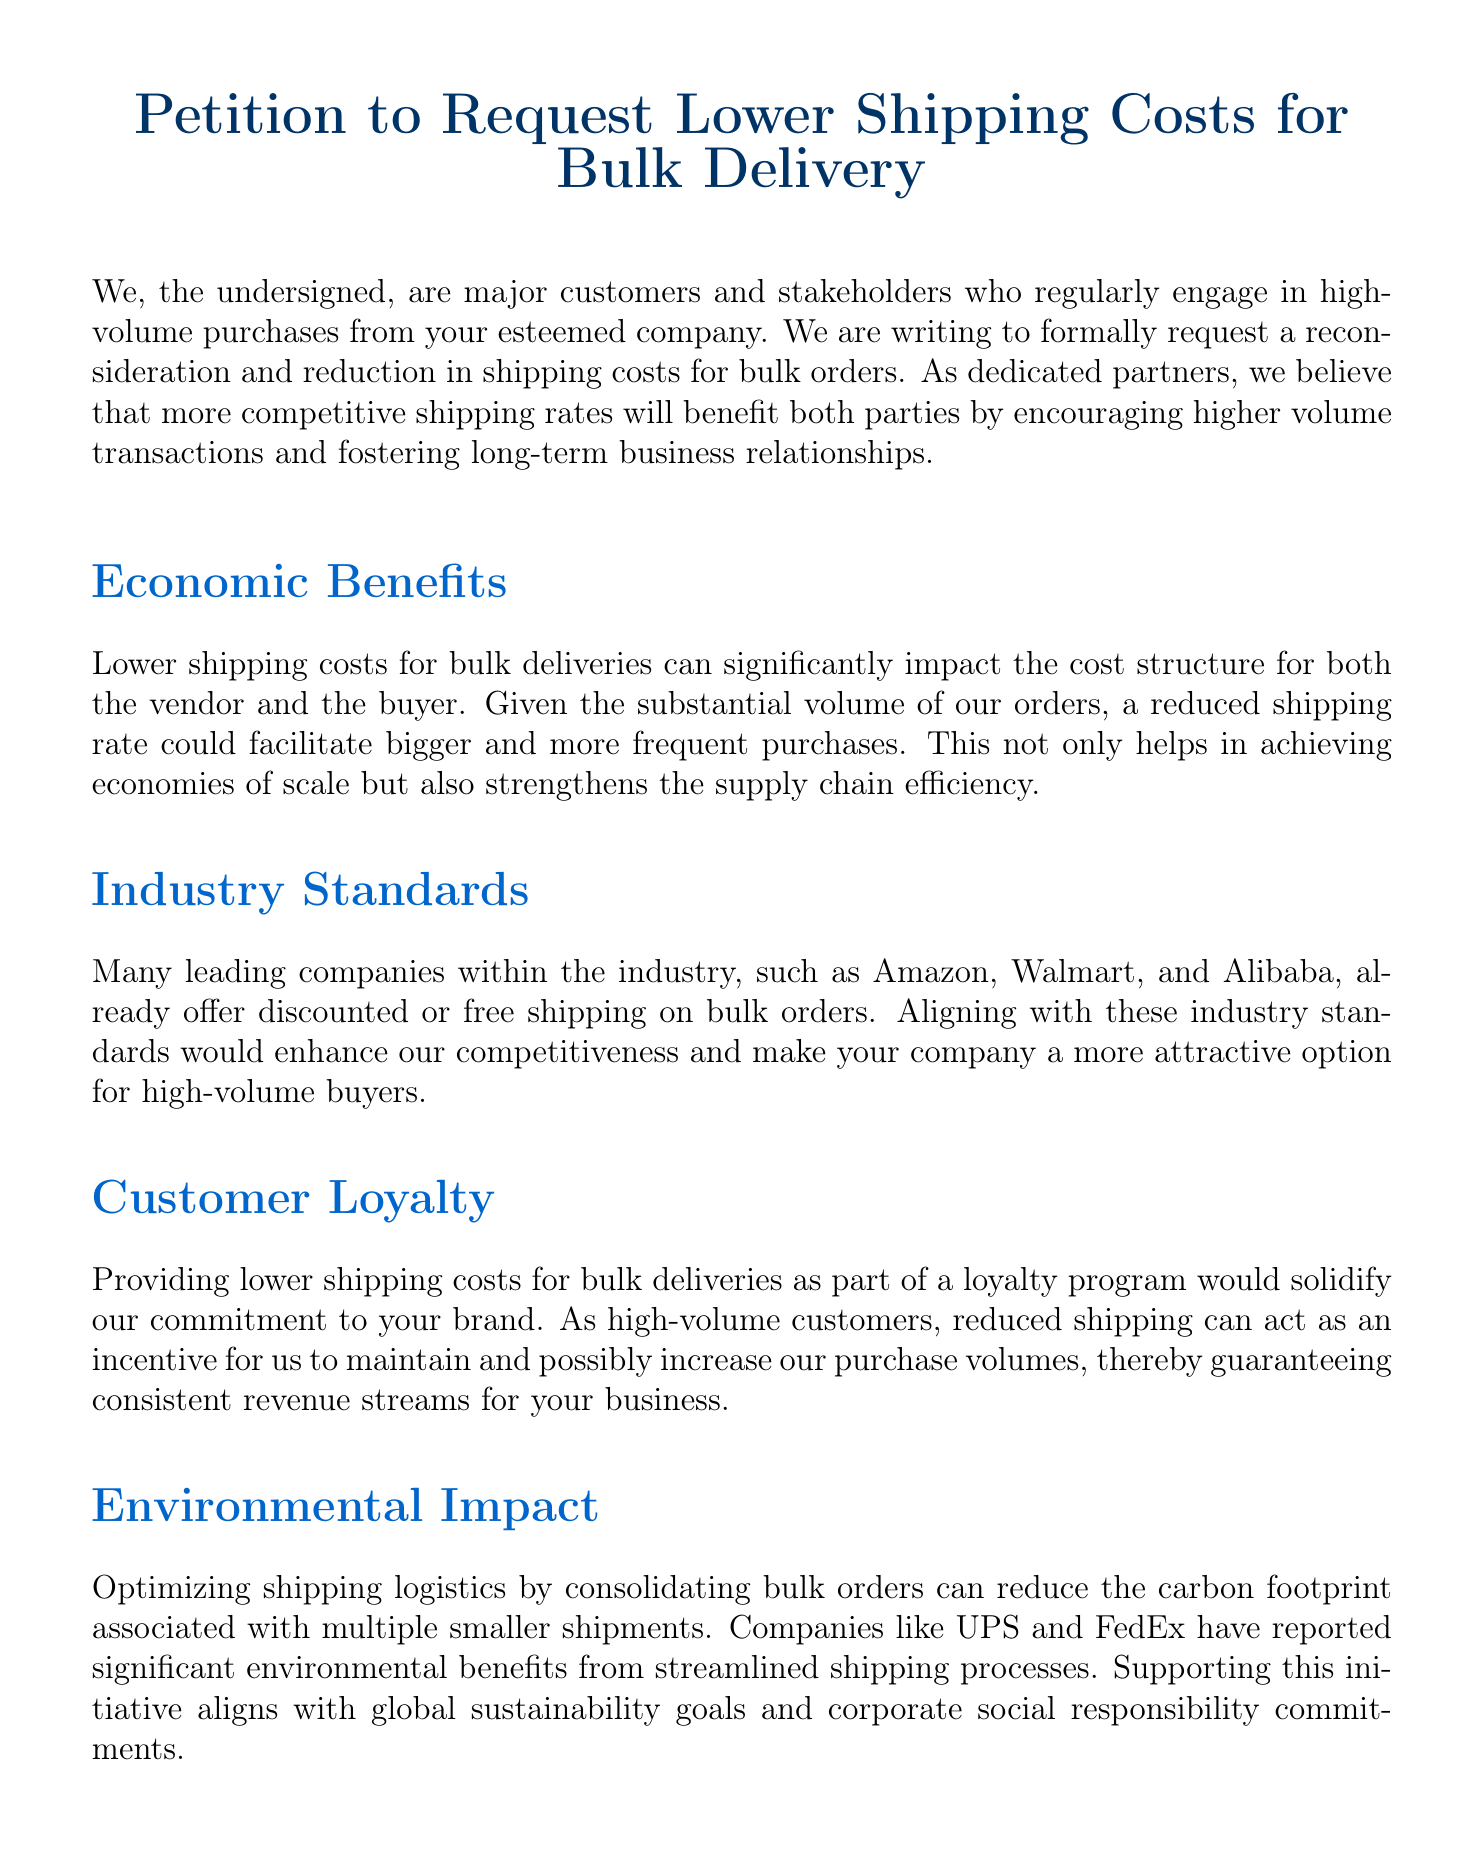What is the title of the petition? The title clearly states the purpose of the document at the top.
Answer: Petition to Request Lower Shipping Costs for Bulk Delivery Who are the stakeholders mentioned in the petition? The first paragraph identifies the group requesting the change, highlighting their role as key customers.
Answer: major customers and stakeholders Which companies are referenced in relation to industry standards? Several companies are mentioned as examples of industry practices regarding shipping costs.
Answer: Amazon, Walmart, and Alibaba What is the desired outcome stated in the petition? The petition explicitly expresses the goal of the document.
Answer: lower shipping costs for bulk orders What benefit does reduced shipping costs offer to the buyer according to the document? The petition discusses several benefits that relate to customer engagement and purchasing behavior.
Answer: bigger and more frequent purchases What environmental benefit is mentioned in the petition? The document highlights an environmental advantage related to shipping practices.
Answer: reduce the carbon footprint Which companies are cited as case study examples? The document provides specific examples of companies that have benefitted from a similar initiative.
Answer: Costco and BJ's Wholesale Club What year is the document signed? The signing date is a typical component of official petitions but is not listed in this context.
Answer: Date What type of policy change is being requested in the petition? The petition seeks a specific adjustment in shipping-related practices.
Answer: lower shipping cost policy 